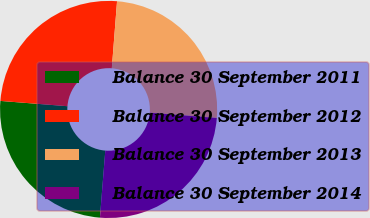Convert chart to OTSL. <chart><loc_0><loc_0><loc_500><loc_500><pie_chart><fcel>Balance 30 September 2011<fcel>Balance 30 September 2012<fcel>Balance 30 September 2013<fcel>Balance 30 September 2014<nl><fcel>24.98%<fcel>24.99%<fcel>25.01%<fcel>25.02%<nl></chart> 